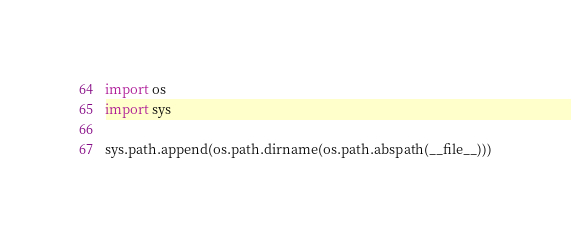Convert code to text. <code><loc_0><loc_0><loc_500><loc_500><_Python_>import os
import sys

sys.path.append(os.path.dirname(os.path.abspath(__file__)))
</code> 